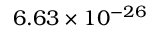<formula> <loc_0><loc_0><loc_500><loc_500>6 . 6 3 \times { 1 0 ^ { - 2 6 } }</formula> 